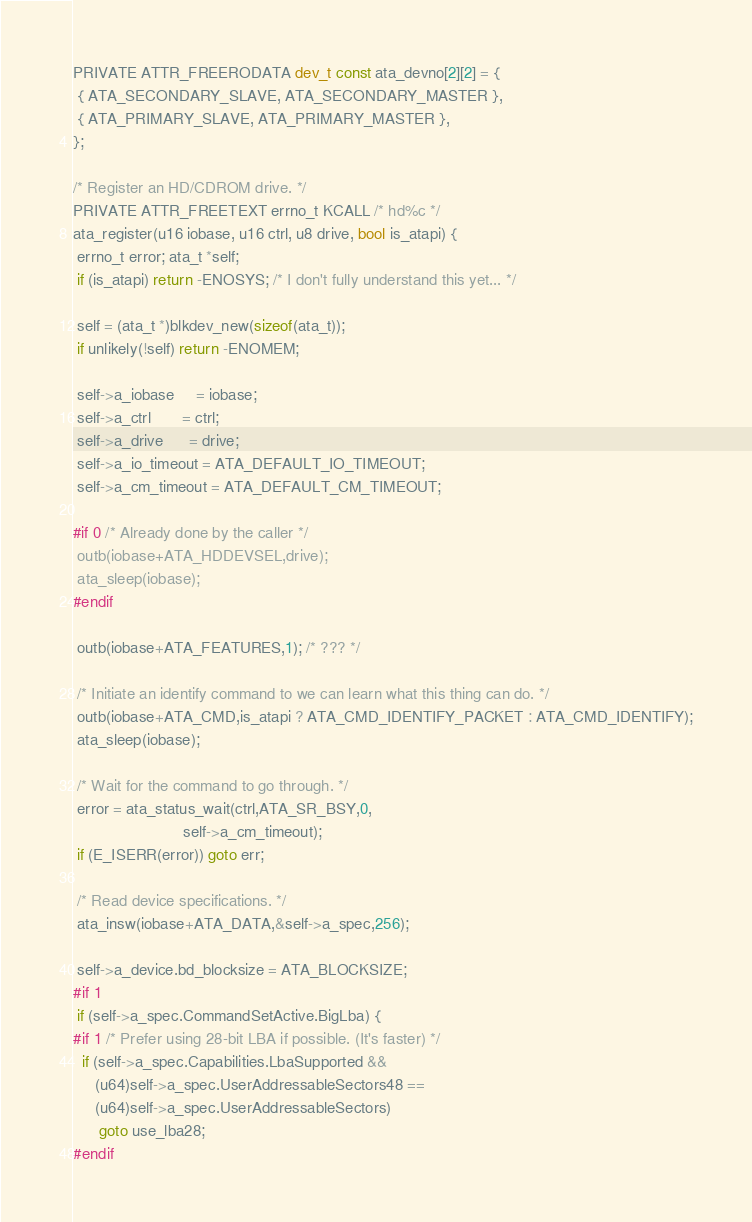Convert code to text. <code><loc_0><loc_0><loc_500><loc_500><_C_>


PRIVATE ATTR_FREERODATA dev_t const ata_devno[2][2] = {
 { ATA_SECONDARY_SLAVE, ATA_SECONDARY_MASTER },
 { ATA_PRIMARY_SLAVE, ATA_PRIMARY_MASTER },
};

/* Register an HD/CDROM drive. */
PRIVATE ATTR_FREETEXT errno_t KCALL /* hd%c */
ata_register(u16 iobase, u16 ctrl, u8 drive, bool is_atapi) {
 errno_t error; ata_t *self;
 if (is_atapi) return -ENOSYS; /* I don't fully understand this yet... */

 self = (ata_t *)blkdev_new(sizeof(ata_t));
 if unlikely(!self) return -ENOMEM;

 self->a_iobase     = iobase;
 self->a_ctrl       = ctrl;
 self->a_drive      = drive;
 self->a_io_timeout = ATA_DEFAULT_IO_TIMEOUT;
 self->a_cm_timeout = ATA_DEFAULT_CM_TIMEOUT;

#if 0 /* Already done by the caller */
 outb(iobase+ATA_HDDEVSEL,drive);
 ata_sleep(iobase);
#endif

 outb(iobase+ATA_FEATURES,1); /* ??? */

 /* Initiate an identify command to we can learn what this thing can do. */
 outb(iobase+ATA_CMD,is_atapi ? ATA_CMD_IDENTIFY_PACKET : ATA_CMD_IDENTIFY);
 ata_sleep(iobase);

 /* Wait for the command to go through. */
 error = ata_status_wait(ctrl,ATA_SR_BSY,0,
                         self->a_cm_timeout);
 if (E_ISERR(error)) goto err;

 /* Read device specifications. */
 ata_insw(iobase+ATA_DATA,&self->a_spec,256);

 self->a_device.bd_blocksize = ATA_BLOCKSIZE;
#if 1
 if (self->a_spec.CommandSetActive.BigLba) {
#if 1 /* Prefer using 28-bit LBA if possible. (It's faster) */
  if (self->a_spec.Capabilities.LbaSupported &&
     (u64)self->a_spec.UserAddressableSectors48 ==
     (u64)self->a_spec.UserAddressableSectors)
      goto use_lba28;
#endif</code> 